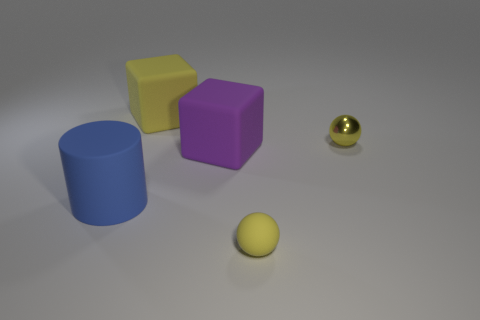Add 4 purple things. How many objects exist? 9 Subtract all balls. How many objects are left? 3 Add 1 small yellow cylinders. How many small yellow cylinders exist? 1 Subtract 0 red spheres. How many objects are left? 5 Subtract all big red balls. Subtract all yellow metallic objects. How many objects are left? 4 Add 3 tiny yellow shiny things. How many tiny yellow shiny things are left? 4 